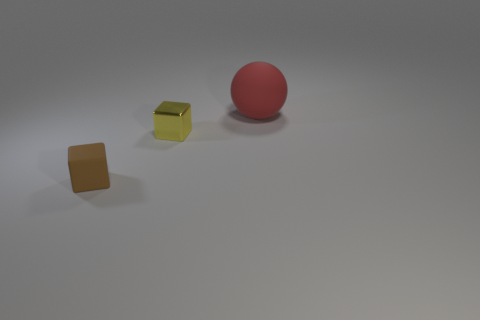Add 3 big balls. How many objects exist? 6 Subtract all balls. How many objects are left? 2 Add 2 tiny yellow blocks. How many tiny yellow blocks are left? 3 Add 3 red matte objects. How many red matte objects exist? 4 Subtract 0 yellow cylinders. How many objects are left? 3 Subtract all purple balls. Subtract all green blocks. How many balls are left? 1 Subtract all brown objects. Subtract all tiny cyan matte blocks. How many objects are left? 2 